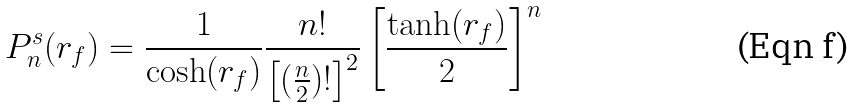<formula> <loc_0><loc_0><loc_500><loc_500>P _ { n } ^ { s } ( r _ { f } ) = \frac { 1 } { \cosh ( r _ { f } ) } \frac { n ! } { \left [ ( \frac { n } { 2 } ) ! \right ] ^ { 2 } } \left [ \frac { \tanh ( r _ { f } ) } { 2 } \right ] ^ { n }</formula> 